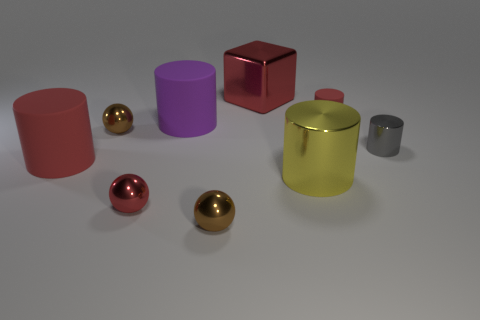Subtract all small red balls. How many balls are left? 2 Subtract all red balls. How many balls are left? 2 Subtract all balls. How many objects are left? 6 Subtract 1 cylinders. How many cylinders are left? 4 Subtract all blue balls. Subtract all blue cubes. How many balls are left? 3 Subtract all yellow cylinders. How many red balls are left? 1 Subtract all tiny purple things. Subtract all yellow shiny cylinders. How many objects are left? 8 Add 5 small rubber cylinders. How many small rubber cylinders are left? 6 Add 8 small purple things. How many small purple things exist? 8 Subtract 0 yellow spheres. How many objects are left? 9 